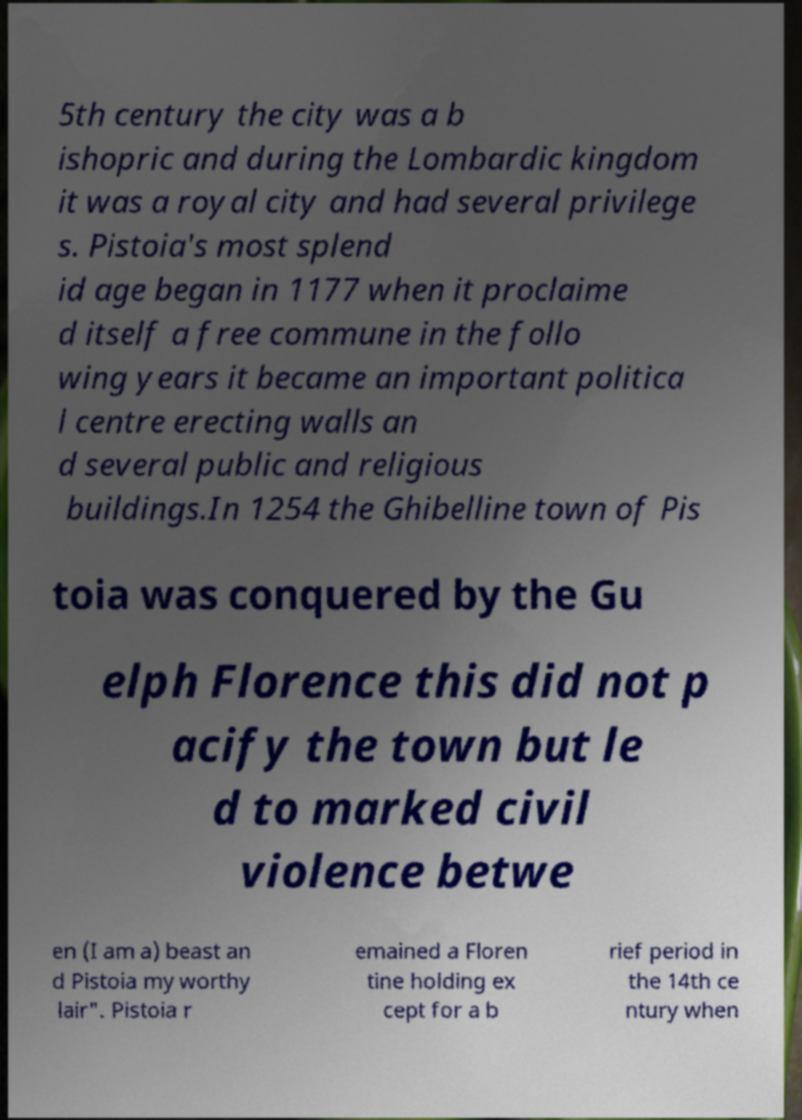I need the written content from this picture converted into text. Can you do that? 5th century the city was a b ishopric and during the Lombardic kingdom it was a royal city and had several privilege s. Pistoia's most splend id age began in 1177 when it proclaime d itself a free commune in the follo wing years it became an important politica l centre erecting walls an d several public and religious buildings.In 1254 the Ghibelline town of Pis toia was conquered by the Gu elph Florence this did not p acify the town but le d to marked civil violence betwe en (I am a) beast an d Pistoia my worthy lair". Pistoia r emained a Floren tine holding ex cept for a b rief period in the 14th ce ntury when 